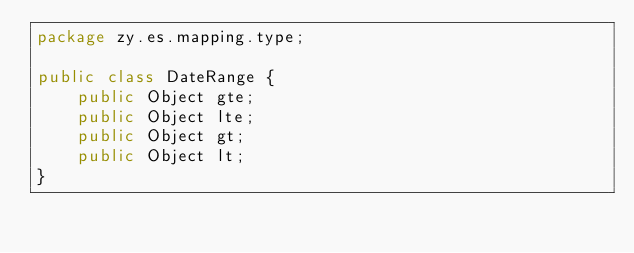<code> <loc_0><loc_0><loc_500><loc_500><_Java_>package zy.es.mapping.type;

public class DateRange {
    public Object gte;
    public Object lte;
    public Object gt;
    public Object lt;
}
</code> 